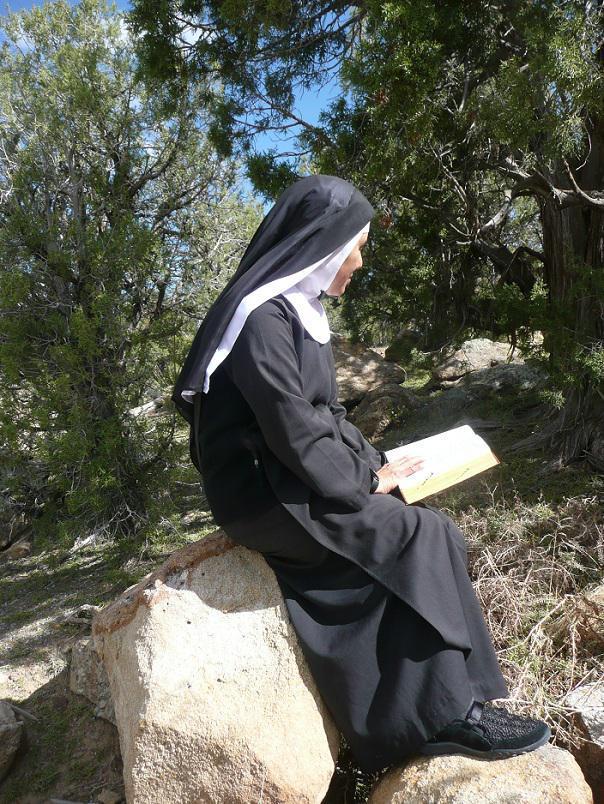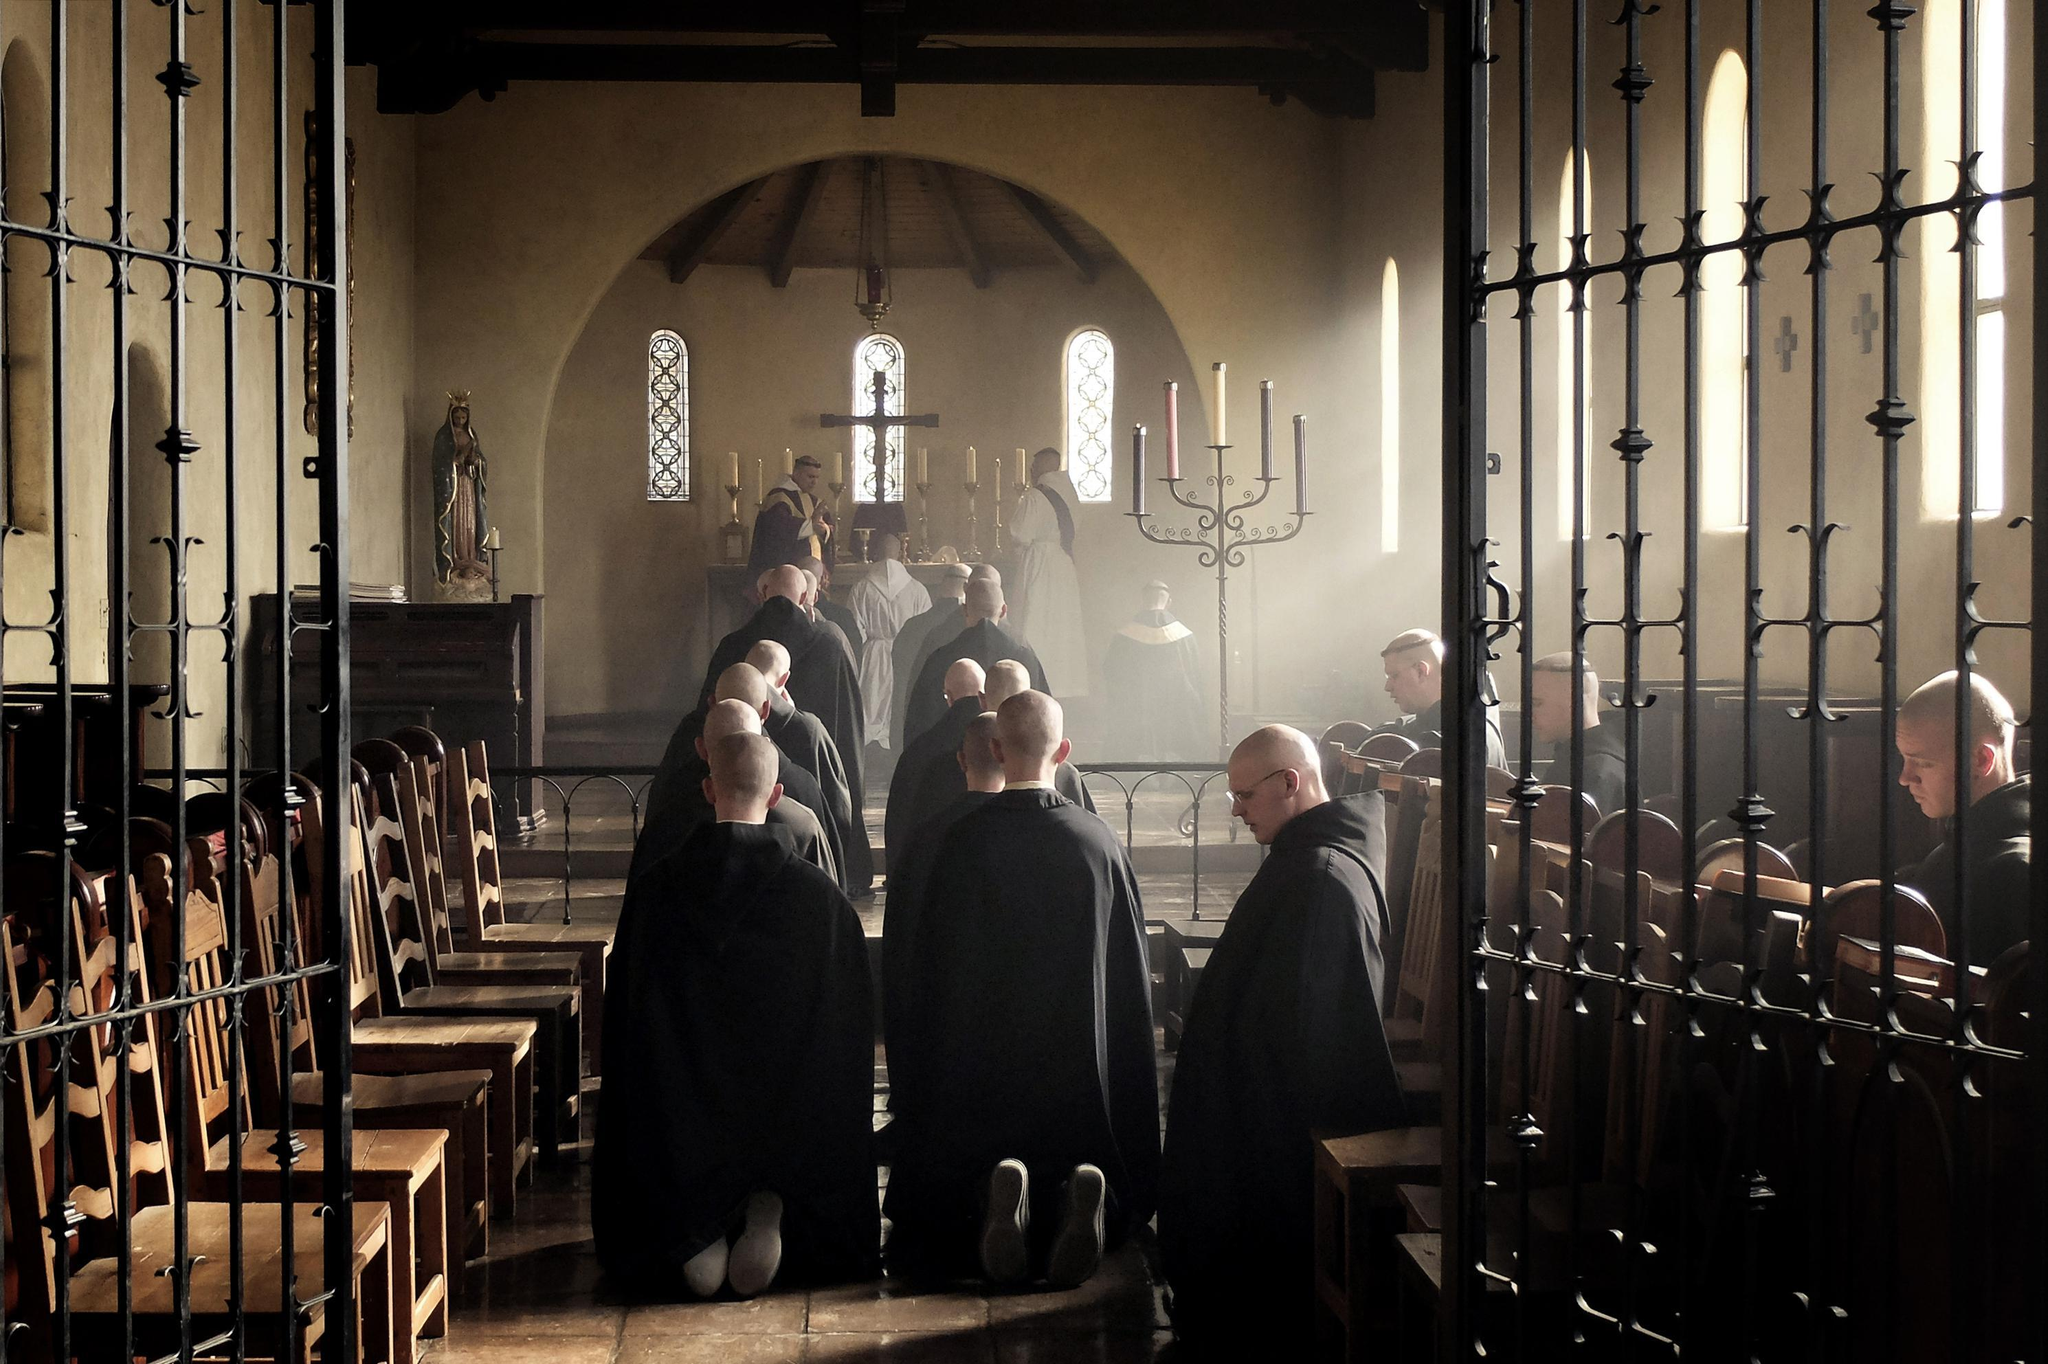The first image is the image on the left, the second image is the image on the right. Analyze the images presented: Is the assertion "At least 10 nuns are posing as a group in one of the pictures." valid? Answer yes or no. No. The first image is the image on the left, the second image is the image on the right. Assess this claim about the two images: "There are women and no men in the left image.". Correct or not? Answer yes or no. Yes. 